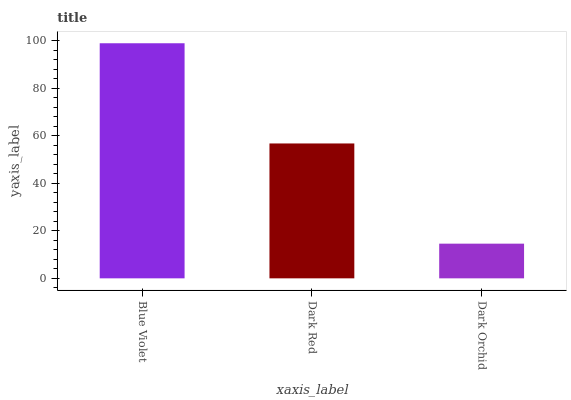Is Dark Orchid the minimum?
Answer yes or no. Yes. Is Blue Violet the maximum?
Answer yes or no. Yes. Is Dark Red the minimum?
Answer yes or no. No. Is Dark Red the maximum?
Answer yes or no. No. Is Blue Violet greater than Dark Red?
Answer yes or no. Yes. Is Dark Red less than Blue Violet?
Answer yes or no. Yes. Is Dark Red greater than Blue Violet?
Answer yes or no. No. Is Blue Violet less than Dark Red?
Answer yes or no. No. Is Dark Red the high median?
Answer yes or no. Yes. Is Dark Red the low median?
Answer yes or no. Yes. Is Dark Orchid the high median?
Answer yes or no. No. Is Dark Orchid the low median?
Answer yes or no. No. 